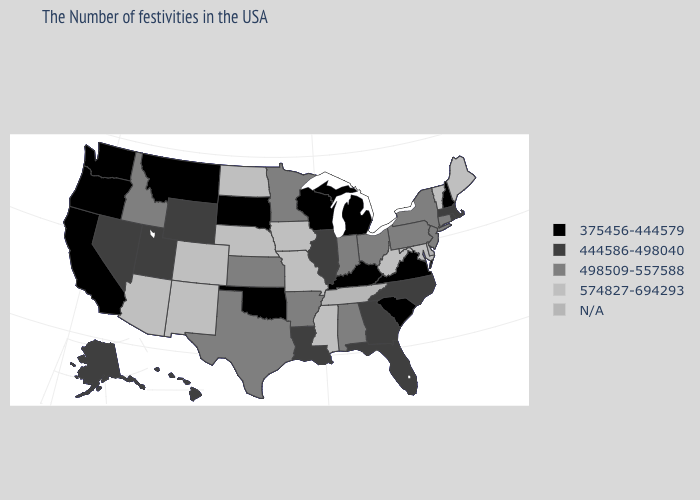Which states hav the highest value in the MidWest?
Answer briefly. Missouri, Iowa, Nebraska, North Dakota. Name the states that have a value in the range N/A?
Short answer required. Delaware, Tennessee. Does the first symbol in the legend represent the smallest category?
Quick response, please. Yes. Among the states that border Texas , which have the lowest value?
Write a very short answer. Oklahoma. Name the states that have a value in the range N/A?
Keep it brief. Delaware, Tennessee. What is the value of New Jersey?
Quick response, please. 498509-557588. Which states have the highest value in the USA?
Answer briefly. Maine, Vermont, Maryland, West Virginia, Mississippi, Missouri, Iowa, Nebraska, North Dakota, Colorado, New Mexico, Arizona. Name the states that have a value in the range 574827-694293?
Keep it brief. Maine, Vermont, Maryland, West Virginia, Mississippi, Missouri, Iowa, Nebraska, North Dakota, Colorado, New Mexico, Arizona. What is the value of Tennessee?
Be succinct. N/A. Name the states that have a value in the range 574827-694293?
Be succinct. Maine, Vermont, Maryland, West Virginia, Mississippi, Missouri, Iowa, Nebraska, North Dakota, Colorado, New Mexico, Arizona. What is the value of New Mexico?
Write a very short answer. 574827-694293. What is the value of Illinois?
Give a very brief answer. 444586-498040. Name the states that have a value in the range 375456-444579?
Write a very short answer. New Hampshire, Virginia, South Carolina, Michigan, Kentucky, Wisconsin, Oklahoma, South Dakota, Montana, California, Washington, Oregon. Name the states that have a value in the range N/A?
Quick response, please. Delaware, Tennessee. What is the lowest value in the USA?
Write a very short answer. 375456-444579. 